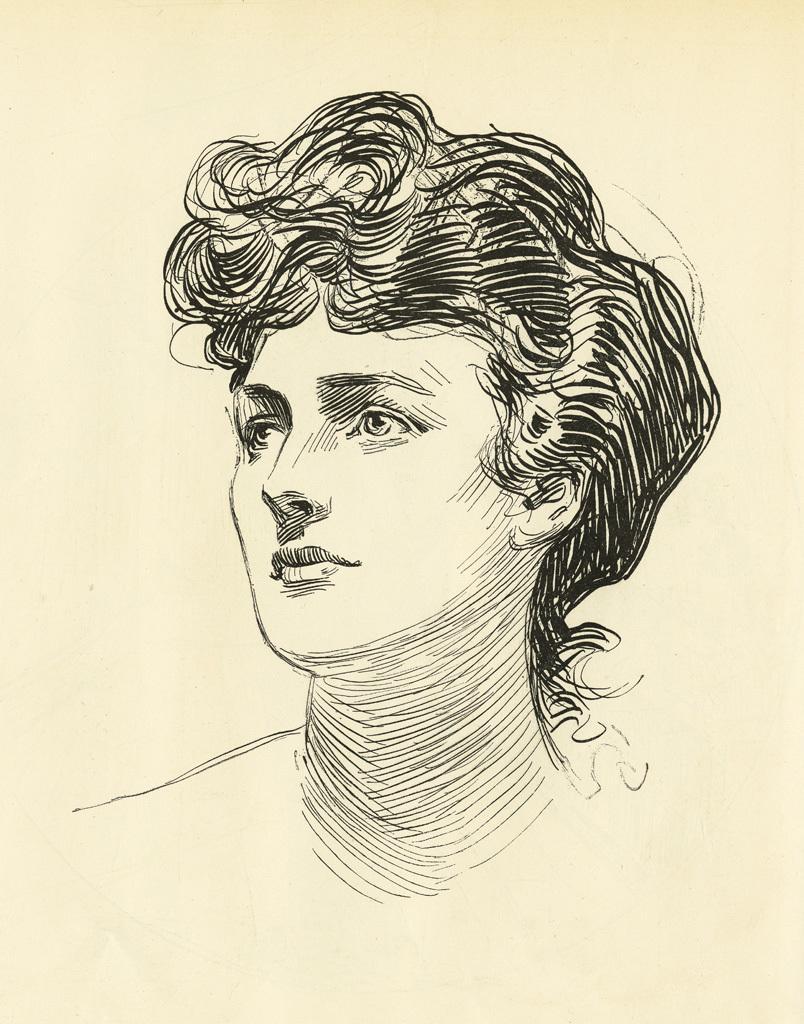Please provide a concise description of this image. In this image, we can see a sketch of a person on the surface. 